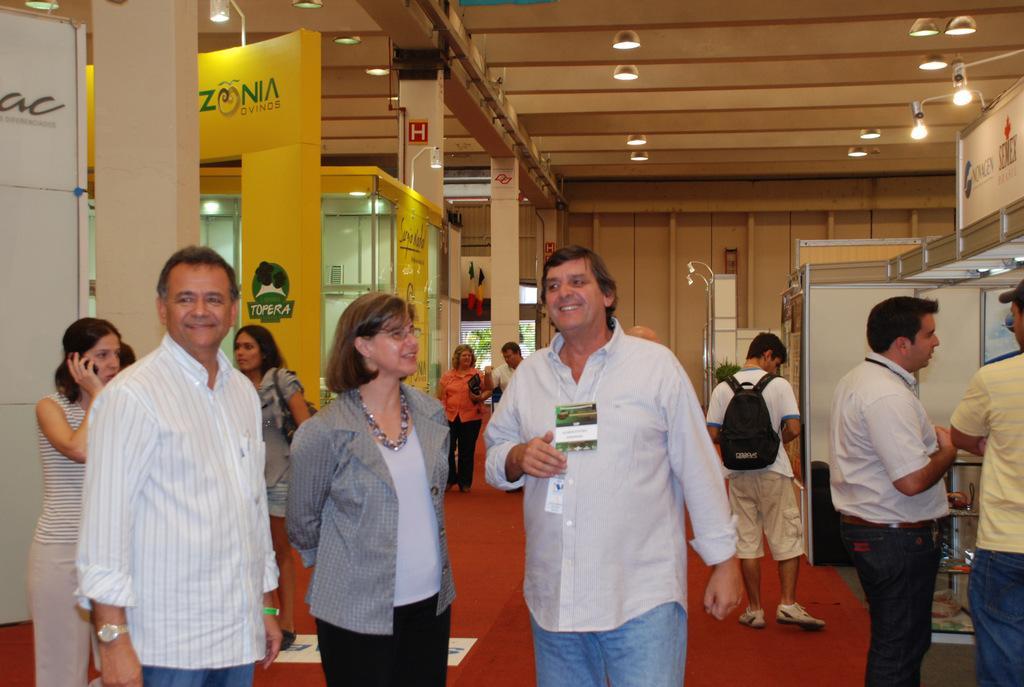How would you summarize this image in a sentence or two? This picture shows few people standing and we see couple of them walking and we see a woman standing and holding a mobile in her hand and we see a man wore a backpack on his back and we see another man with a id card and we see a woman wore spectacles on her face and we see lights to the roof. 